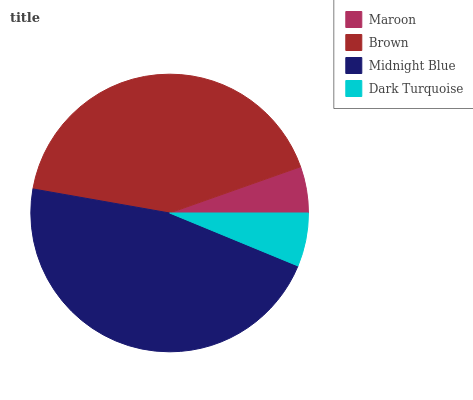Is Maroon the minimum?
Answer yes or no. Yes. Is Midnight Blue the maximum?
Answer yes or no. Yes. Is Brown the minimum?
Answer yes or no. No. Is Brown the maximum?
Answer yes or no. No. Is Brown greater than Maroon?
Answer yes or no. Yes. Is Maroon less than Brown?
Answer yes or no. Yes. Is Maroon greater than Brown?
Answer yes or no. No. Is Brown less than Maroon?
Answer yes or no. No. Is Brown the high median?
Answer yes or no. Yes. Is Dark Turquoise the low median?
Answer yes or no. Yes. Is Midnight Blue the high median?
Answer yes or no. No. Is Midnight Blue the low median?
Answer yes or no. No. 